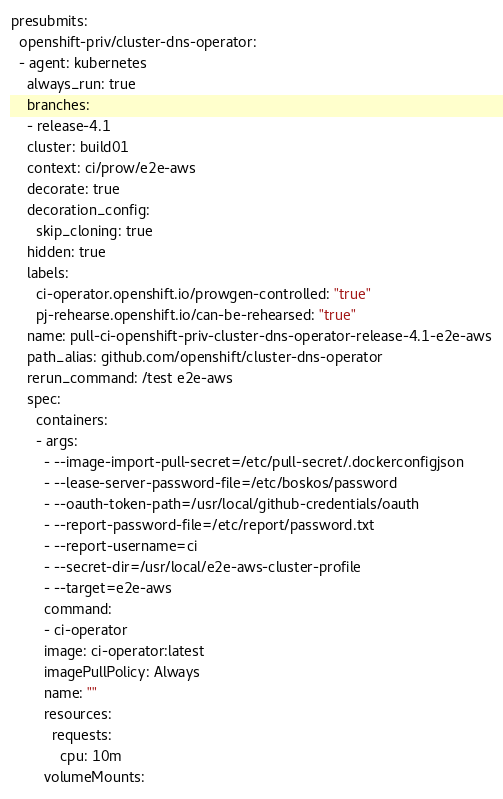Convert code to text. <code><loc_0><loc_0><loc_500><loc_500><_YAML_>presubmits:
  openshift-priv/cluster-dns-operator:
  - agent: kubernetes
    always_run: true
    branches:
    - release-4.1
    cluster: build01
    context: ci/prow/e2e-aws
    decorate: true
    decoration_config:
      skip_cloning: true
    hidden: true
    labels:
      ci-operator.openshift.io/prowgen-controlled: "true"
      pj-rehearse.openshift.io/can-be-rehearsed: "true"
    name: pull-ci-openshift-priv-cluster-dns-operator-release-4.1-e2e-aws
    path_alias: github.com/openshift/cluster-dns-operator
    rerun_command: /test e2e-aws
    spec:
      containers:
      - args:
        - --image-import-pull-secret=/etc/pull-secret/.dockerconfigjson
        - --lease-server-password-file=/etc/boskos/password
        - --oauth-token-path=/usr/local/github-credentials/oauth
        - --report-password-file=/etc/report/password.txt
        - --report-username=ci
        - --secret-dir=/usr/local/e2e-aws-cluster-profile
        - --target=e2e-aws
        command:
        - ci-operator
        image: ci-operator:latest
        imagePullPolicy: Always
        name: ""
        resources:
          requests:
            cpu: 10m
        volumeMounts:</code> 